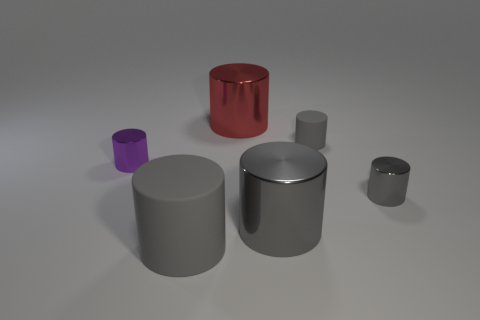How many other things are there of the same color as the large matte thing?
Your answer should be very brief. 3. There is a tiny object that is left of the tiny rubber object; what number of big red metallic objects are on the left side of it?
Make the answer very short. 0. There is a large red object; are there any big red metallic objects behind it?
Give a very brief answer. No. There is a big metallic thing that is behind the small gray object in front of the purple shiny cylinder; what is its shape?
Your answer should be compact. Cylinder. Is the number of large things that are in front of the big gray rubber object less than the number of tiny gray cylinders in front of the large gray shiny cylinder?
Provide a short and direct response. No. There is a tiny matte object that is the same shape as the tiny gray shiny object; what is its color?
Offer a terse response. Gray. What number of large cylinders are behind the big gray rubber thing and on the left side of the large red metal object?
Ensure brevity in your answer.  0. Is the number of matte objects that are in front of the small purple metallic thing greater than the number of gray things to the left of the big red metal cylinder?
Give a very brief answer. No. The purple metal thing is what size?
Your response must be concise. Small. Are there any big yellow matte things that have the same shape as the tiny matte thing?
Offer a terse response. No. 